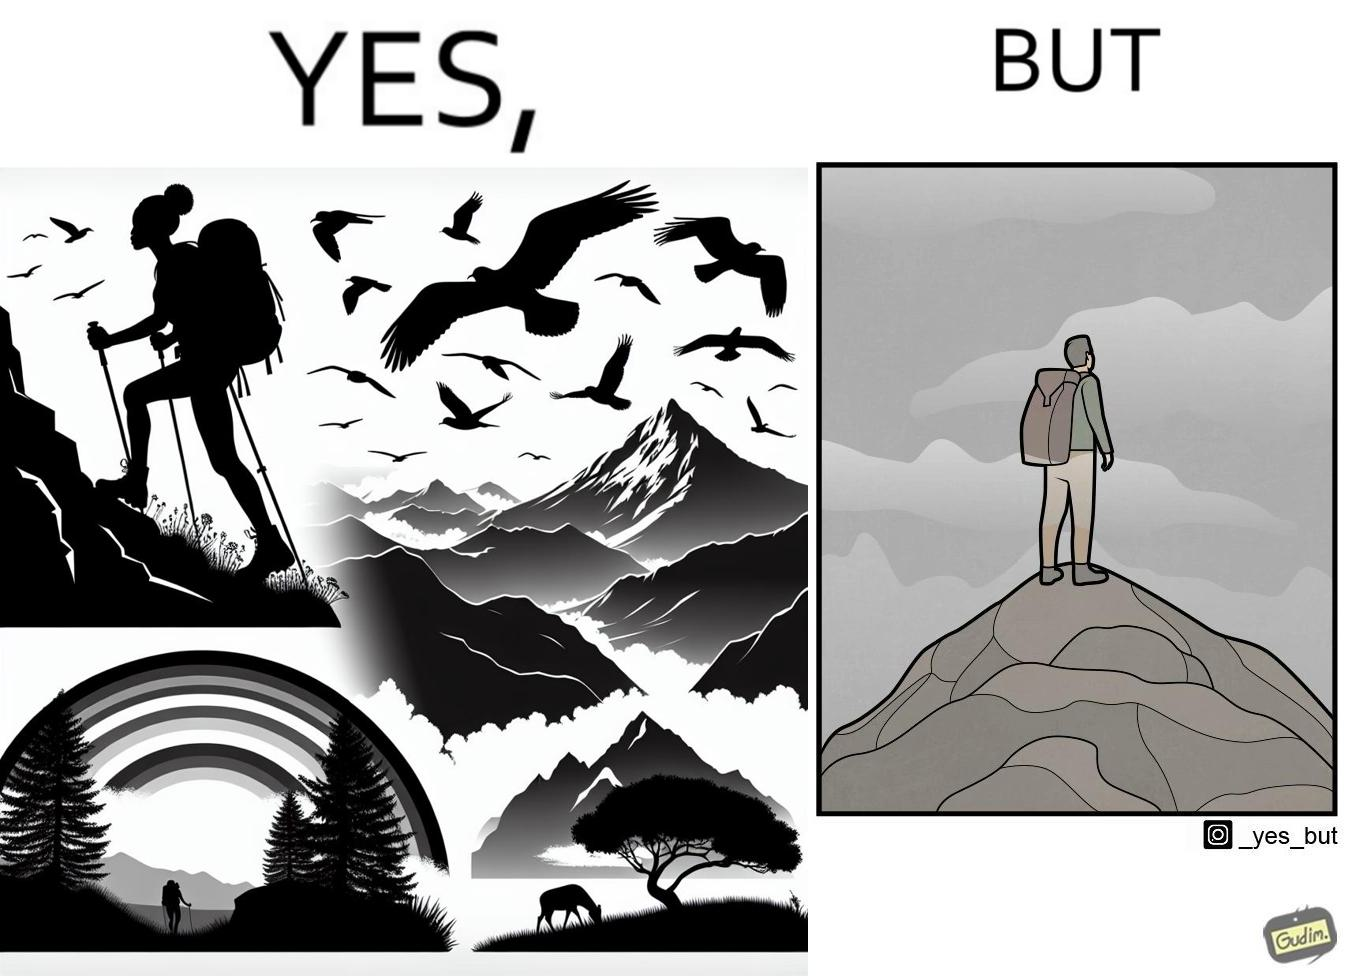Describe the contrast between the left and right parts of this image. In the left part of the image: a mountaineer climbing up the mountain, enjoying the view, birds are flying, rainbow is visible In the right part of the image: a mountaineer is at the peak of the mountain but nothing is visible due to clouds 